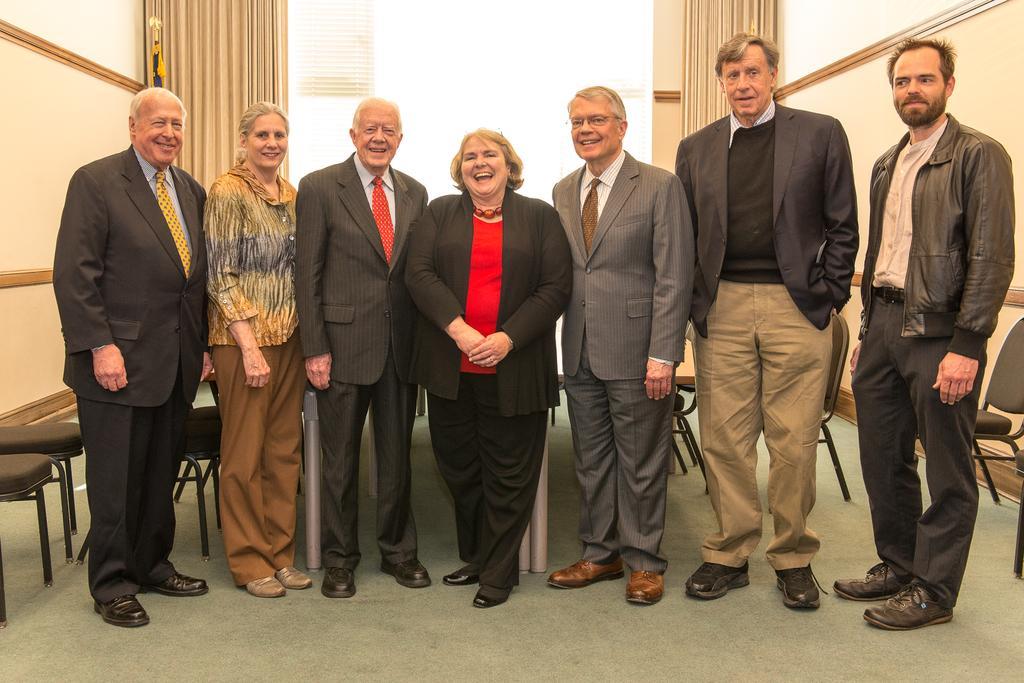How would you summarize this image in a sentence or two? This picture is clicked inside the room. In the center we can see the group of persons standing on the ground and we can see the chairs and tables are placed on the ground, the ground is covered with the floor mat. In the background we can see the window, wall and the curtains. 